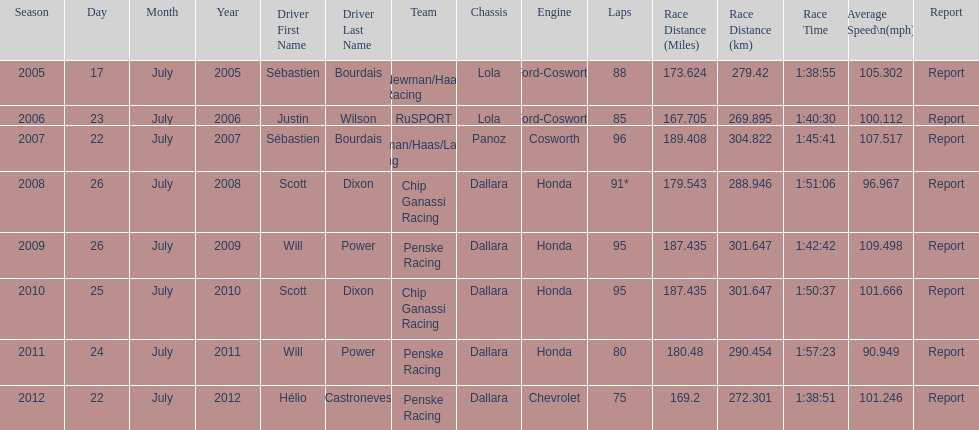How many total honda engines were there? 4. 